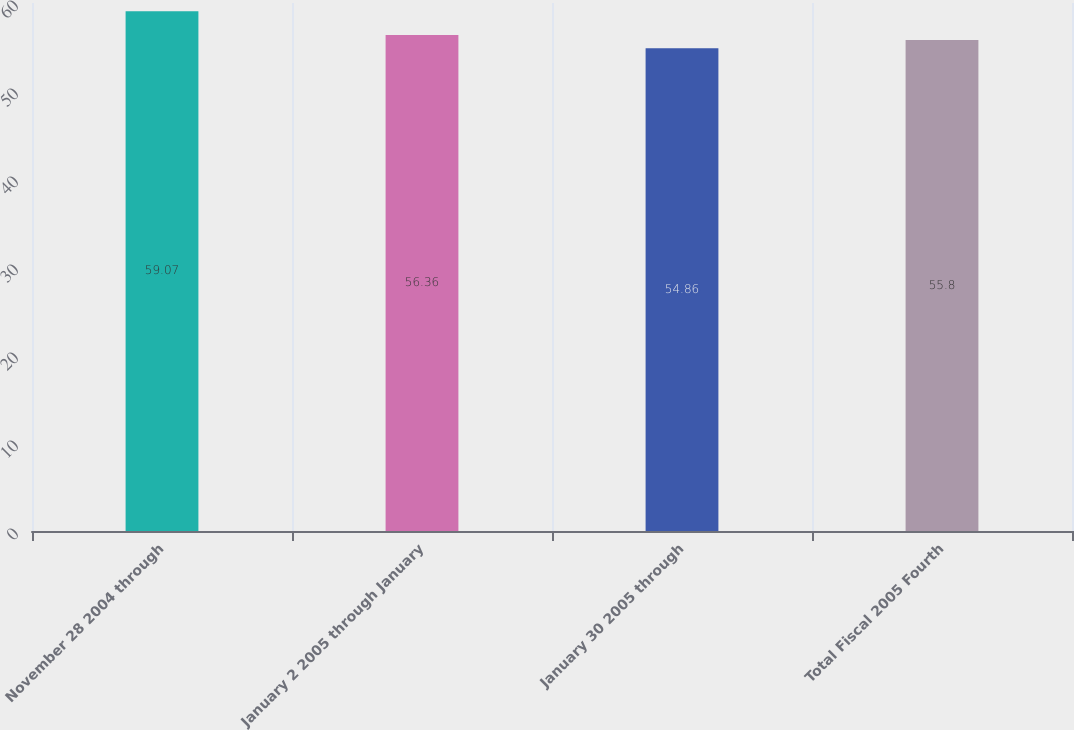<chart> <loc_0><loc_0><loc_500><loc_500><bar_chart><fcel>November 28 2004 through<fcel>January 2 2005 through January<fcel>January 30 2005 through<fcel>Total Fiscal 2005 Fourth<nl><fcel>59.07<fcel>56.36<fcel>54.86<fcel>55.8<nl></chart> 